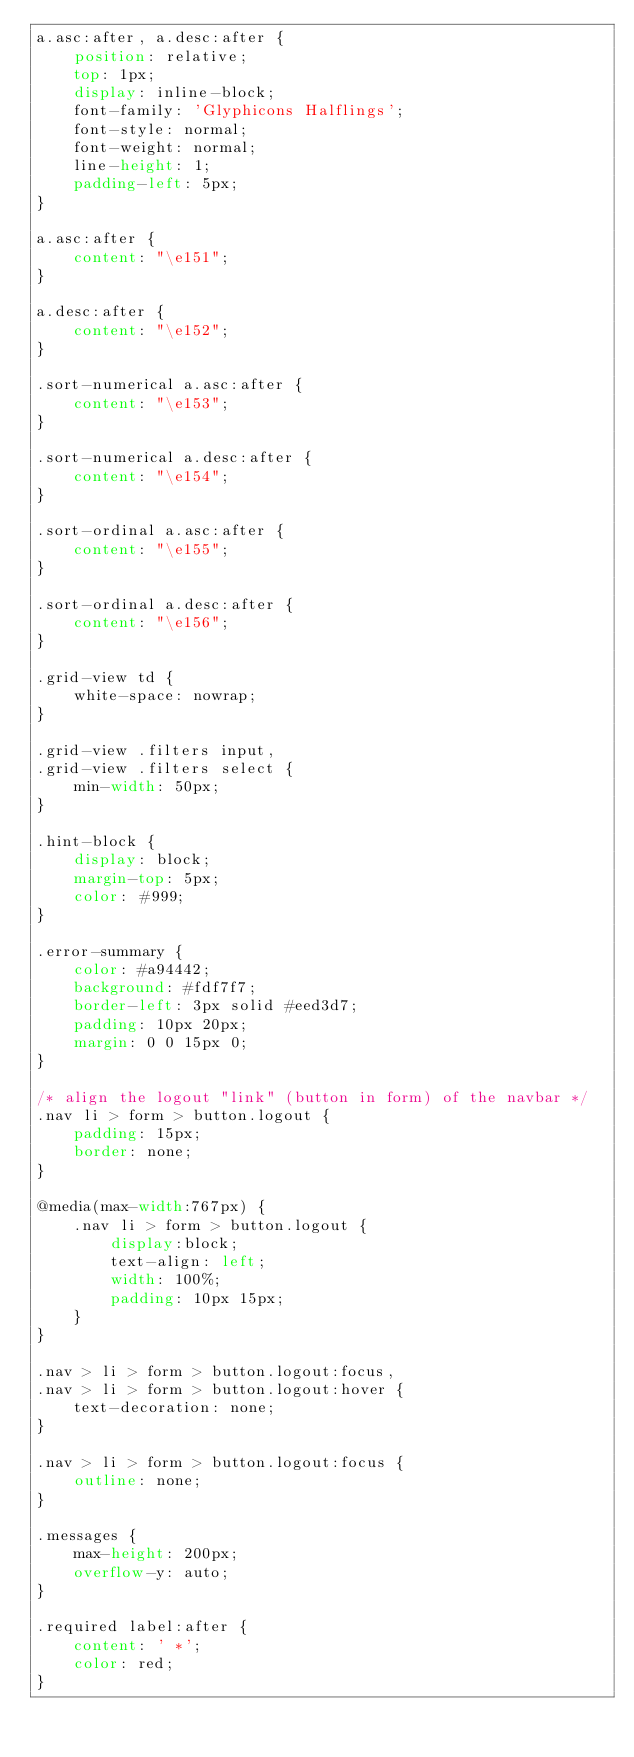Convert code to text. <code><loc_0><loc_0><loc_500><loc_500><_CSS_>a.asc:after, a.desc:after {
    position: relative;
    top: 1px;
    display: inline-block;
    font-family: 'Glyphicons Halflings';
    font-style: normal;
    font-weight: normal;
    line-height: 1;
    padding-left: 5px;
}

a.asc:after {
    content: "\e151";
}

a.desc:after {
    content: "\e152";
}

.sort-numerical a.asc:after {
    content: "\e153";
}

.sort-numerical a.desc:after {
    content: "\e154";
}

.sort-ordinal a.asc:after {
    content: "\e155";
}

.sort-ordinal a.desc:after {
    content: "\e156";
}

.grid-view td {
    white-space: nowrap;
}

.grid-view .filters input,
.grid-view .filters select {
    min-width: 50px;
}

.hint-block {
    display: block;
    margin-top: 5px;
    color: #999;
}

.error-summary {
    color: #a94442;
    background: #fdf7f7;
    border-left: 3px solid #eed3d7;
    padding: 10px 20px;
    margin: 0 0 15px 0;
}

/* align the logout "link" (button in form) of the navbar */
.nav li > form > button.logout {
    padding: 15px;
    border: none;
}

@media(max-width:767px) {
    .nav li > form > button.logout {
        display:block;
        text-align: left;
        width: 100%;
        padding: 10px 15px;
    }
}

.nav > li > form > button.logout:focus,
.nav > li > form > button.logout:hover {
    text-decoration: none;
}

.nav > li > form > button.logout:focus {
    outline: none;
}

.messages {
    max-height: 200px;
    overflow-y: auto;
}

.required label:after {
    content: ' *';
    color: red;
}</code> 